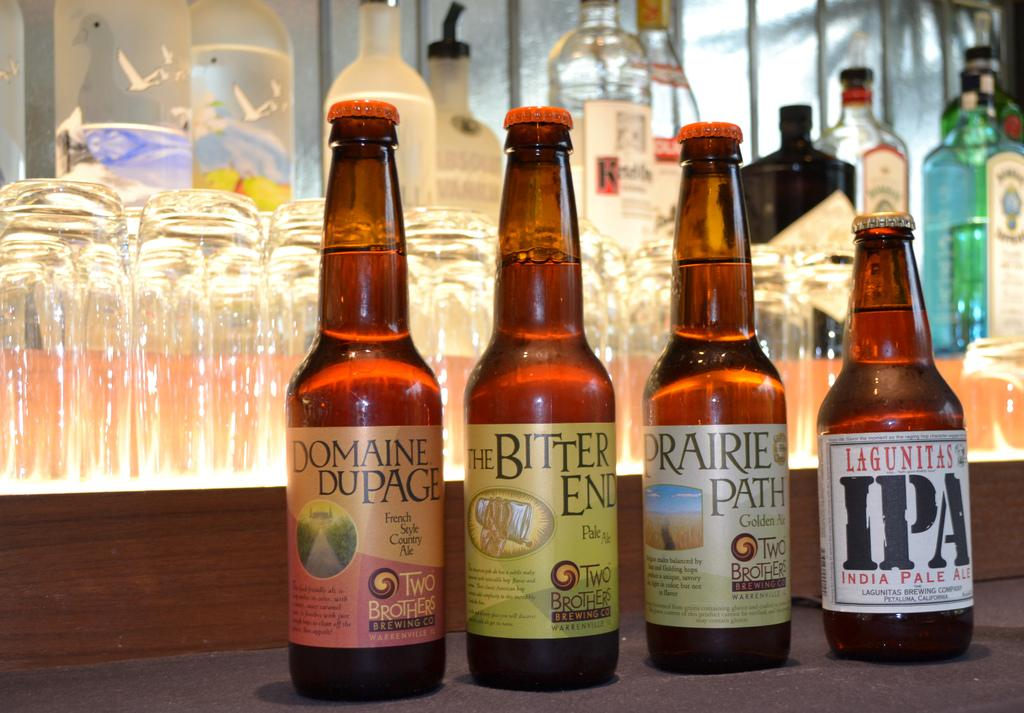<image>
Share a concise interpretation of the image provided. Four bottles of beer sit on the table the far right being IPA. 